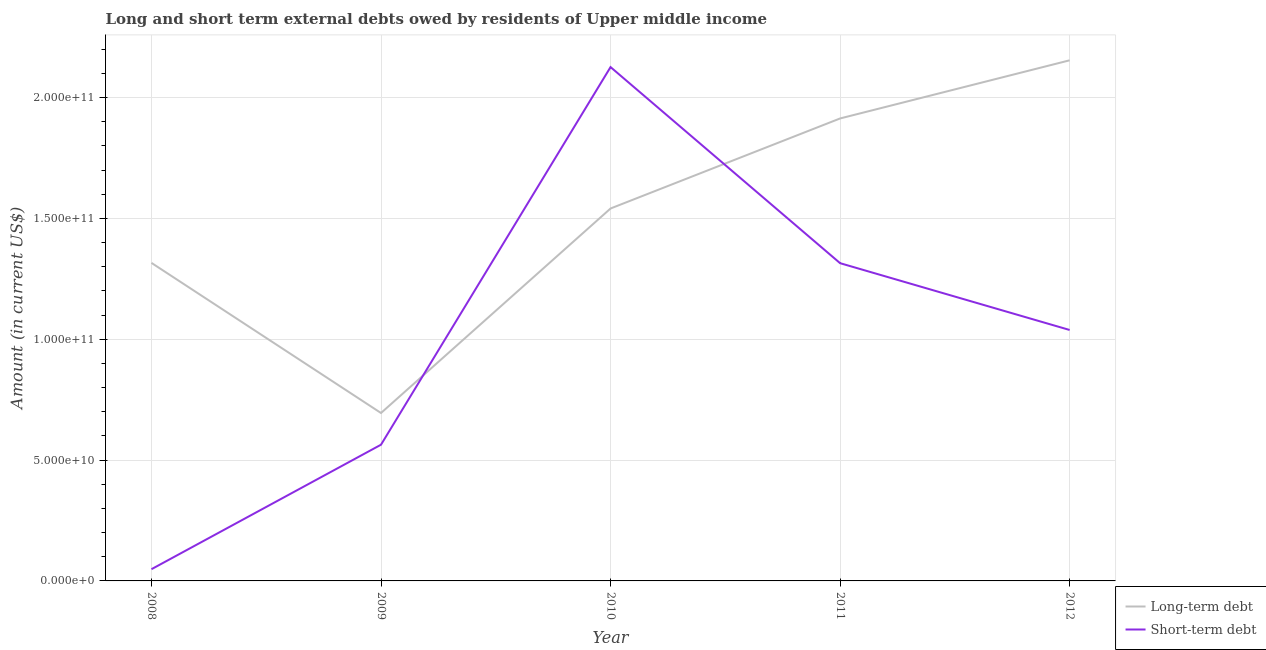Does the line corresponding to long-term debts owed by residents intersect with the line corresponding to short-term debts owed by residents?
Offer a very short reply. Yes. What is the long-term debts owed by residents in 2010?
Provide a short and direct response. 1.54e+11. Across all years, what is the maximum long-term debts owed by residents?
Ensure brevity in your answer.  2.15e+11. Across all years, what is the minimum long-term debts owed by residents?
Your response must be concise. 6.95e+1. What is the total long-term debts owed by residents in the graph?
Your answer should be very brief. 7.62e+11. What is the difference between the short-term debts owed by residents in 2009 and that in 2010?
Your response must be concise. -1.56e+11. What is the difference between the long-term debts owed by residents in 2008 and the short-term debts owed by residents in 2010?
Your response must be concise. -8.10e+1. What is the average long-term debts owed by residents per year?
Keep it short and to the point. 1.52e+11. In the year 2012, what is the difference between the long-term debts owed by residents and short-term debts owed by residents?
Provide a short and direct response. 1.12e+11. What is the ratio of the long-term debts owed by residents in 2009 to that in 2010?
Provide a short and direct response. 0.45. Is the long-term debts owed by residents in 2009 less than that in 2011?
Provide a succinct answer. Yes. Is the difference between the short-term debts owed by residents in 2008 and 2011 greater than the difference between the long-term debts owed by residents in 2008 and 2011?
Your response must be concise. No. What is the difference between the highest and the second highest long-term debts owed by residents?
Provide a short and direct response. 2.41e+1. What is the difference between the highest and the lowest long-term debts owed by residents?
Ensure brevity in your answer.  1.46e+11. In how many years, is the long-term debts owed by residents greater than the average long-term debts owed by residents taken over all years?
Offer a terse response. 3. Is the short-term debts owed by residents strictly greater than the long-term debts owed by residents over the years?
Offer a very short reply. No. What is the difference between two consecutive major ticks on the Y-axis?
Provide a succinct answer. 5.00e+1. Are the values on the major ticks of Y-axis written in scientific E-notation?
Offer a very short reply. Yes. Does the graph contain grids?
Provide a short and direct response. Yes. Where does the legend appear in the graph?
Provide a short and direct response. Bottom right. How are the legend labels stacked?
Ensure brevity in your answer.  Vertical. What is the title of the graph?
Keep it short and to the point. Long and short term external debts owed by residents of Upper middle income. What is the label or title of the X-axis?
Your response must be concise. Year. What is the label or title of the Y-axis?
Offer a very short reply. Amount (in current US$). What is the Amount (in current US$) in Long-term debt in 2008?
Offer a very short reply. 1.32e+11. What is the Amount (in current US$) in Short-term debt in 2008?
Provide a succinct answer. 4.85e+09. What is the Amount (in current US$) of Long-term debt in 2009?
Ensure brevity in your answer.  6.95e+1. What is the Amount (in current US$) in Short-term debt in 2009?
Your answer should be very brief. 5.64e+1. What is the Amount (in current US$) in Long-term debt in 2010?
Keep it short and to the point. 1.54e+11. What is the Amount (in current US$) in Short-term debt in 2010?
Your answer should be compact. 2.13e+11. What is the Amount (in current US$) in Long-term debt in 2011?
Make the answer very short. 1.91e+11. What is the Amount (in current US$) of Short-term debt in 2011?
Make the answer very short. 1.31e+11. What is the Amount (in current US$) in Long-term debt in 2012?
Provide a succinct answer. 2.15e+11. What is the Amount (in current US$) of Short-term debt in 2012?
Make the answer very short. 1.04e+11. Across all years, what is the maximum Amount (in current US$) of Long-term debt?
Ensure brevity in your answer.  2.15e+11. Across all years, what is the maximum Amount (in current US$) of Short-term debt?
Your answer should be very brief. 2.13e+11. Across all years, what is the minimum Amount (in current US$) in Long-term debt?
Give a very brief answer. 6.95e+1. Across all years, what is the minimum Amount (in current US$) of Short-term debt?
Your answer should be very brief. 4.85e+09. What is the total Amount (in current US$) of Long-term debt in the graph?
Give a very brief answer. 7.62e+11. What is the total Amount (in current US$) of Short-term debt in the graph?
Ensure brevity in your answer.  5.09e+11. What is the difference between the Amount (in current US$) in Long-term debt in 2008 and that in 2009?
Give a very brief answer. 6.21e+1. What is the difference between the Amount (in current US$) of Short-term debt in 2008 and that in 2009?
Offer a terse response. -5.15e+1. What is the difference between the Amount (in current US$) of Long-term debt in 2008 and that in 2010?
Your response must be concise. -2.25e+1. What is the difference between the Amount (in current US$) in Short-term debt in 2008 and that in 2010?
Your response must be concise. -2.08e+11. What is the difference between the Amount (in current US$) of Long-term debt in 2008 and that in 2011?
Give a very brief answer. -5.98e+1. What is the difference between the Amount (in current US$) of Short-term debt in 2008 and that in 2011?
Make the answer very short. -1.27e+11. What is the difference between the Amount (in current US$) of Long-term debt in 2008 and that in 2012?
Your response must be concise. -8.38e+1. What is the difference between the Amount (in current US$) in Short-term debt in 2008 and that in 2012?
Make the answer very short. -9.90e+1. What is the difference between the Amount (in current US$) in Long-term debt in 2009 and that in 2010?
Your response must be concise. -8.46e+1. What is the difference between the Amount (in current US$) in Short-term debt in 2009 and that in 2010?
Offer a terse response. -1.56e+11. What is the difference between the Amount (in current US$) of Long-term debt in 2009 and that in 2011?
Offer a terse response. -1.22e+11. What is the difference between the Amount (in current US$) in Short-term debt in 2009 and that in 2011?
Your response must be concise. -7.51e+1. What is the difference between the Amount (in current US$) of Long-term debt in 2009 and that in 2012?
Your answer should be very brief. -1.46e+11. What is the difference between the Amount (in current US$) in Short-term debt in 2009 and that in 2012?
Your response must be concise. -4.75e+1. What is the difference between the Amount (in current US$) in Long-term debt in 2010 and that in 2011?
Ensure brevity in your answer.  -3.73e+1. What is the difference between the Amount (in current US$) of Short-term debt in 2010 and that in 2011?
Offer a very short reply. 8.11e+1. What is the difference between the Amount (in current US$) of Long-term debt in 2010 and that in 2012?
Your answer should be very brief. -6.13e+1. What is the difference between the Amount (in current US$) of Short-term debt in 2010 and that in 2012?
Offer a terse response. 1.09e+11. What is the difference between the Amount (in current US$) of Long-term debt in 2011 and that in 2012?
Offer a terse response. -2.41e+1. What is the difference between the Amount (in current US$) of Short-term debt in 2011 and that in 2012?
Offer a very short reply. 2.76e+1. What is the difference between the Amount (in current US$) of Long-term debt in 2008 and the Amount (in current US$) of Short-term debt in 2009?
Make the answer very short. 7.52e+1. What is the difference between the Amount (in current US$) of Long-term debt in 2008 and the Amount (in current US$) of Short-term debt in 2010?
Your response must be concise. -8.10e+1. What is the difference between the Amount (in current US$) of Long-term debt in 2008 and the Amount (in current US$) of Short-term debt in 2011?
Provide a short and direct response. 1.19e+08. What is the difference between the Amount (in current US$) in Long-term debt in 2008 and the Amount (in current US$) in Short-term debt in 2012?
Make the answer very short. 2.78e+1. What is the difference between the Amount (in current US$) in Long-term debt in 2009 and the Amount (in current US$) in Short-term debt in 2010?
Your answer should be very brief. -1.43e+11. What is the difference between the Amount (in current US$) of Long-term debt in 2009 and the Amount (in current US$) of Short-term debt in 2011?
Offer a terse response. -6.20e+1. What is the difference between the Amount (in current US$) of Long-term debt in 2009 and the Amount (in current US$) of Short-term debt in 2012?
Make the answer very short. -3.44e+1. What is the difference between the Amount (in current US$) in Long-term debt in 2010 and the Amount (in current US$) in Short-term debt in 2011?
Keep it short and to the point. 2.26e+1. What is the difference between the Amount (in current US$) of Long-term debt in 2010 and the Amount (in current US$) of Short-term debt in 2012?
Keep it short and to the point. 5.03e+1. What is the difference between the Amount (in current US$) of Long-term debt in 2011 and the Amount (in current US$) of Short-term debt in 2012?
Offer a terse response. 8.75e+1. What is the average Amount (in current US$) of Long-term debt per year?
Your answer should be compact. 1.52e+11. What is the average Amount (in current US$) of Short-term debt per year?
Provide a succinct answer. 1.02e+11. In the year 2008, what is the difference between the Amount (in current US$) in Long-term debt and Amount (in current US$) in Short-term debt?
Your answer should be compact. 1.27e+11. In the year 2009, what is the difference between the Amount (in current US$) of Long-term debt and Amount (in current US$) of Short-term debt?
Provide a short and direct response. 1.31e+1. In the year 2010, what is the difference between the Amount (in current US$) of Long-term debt and Amount (in current US$) of Short-term debt?
Your answer should be very brief. -5.85e+1. In the year 2011, what is the difference between the Amount (in current US$) of Long-term debt and Amount (in current US$) of Short-term debt?
Ensure brevity in your answer.  5.99e+1. In the year 2012, what is the difference between the Amount (in current US$) of Long-term debt and Amount (in current US$) of Short-term debt?
Ensure brevity in your answer.  1.12e+11. What is the ratio of the Amount (in current US$) of Long-term debt in 2008 to that in 2009?
Provide a succinct answer. 1.89. What is the ratio of the Amount (in current US$) in Short-term debt in 2008 to that in 2009?
Offer a very short reply. 0.09. What is the ratio of the Amount (in current US$) of Long-term debt in 2008 to that in 2010?
Provide a short and direct response. 0.85. What is the ratio of the Amount (in current US$) in Short-term debt in 2008 to that in 2010?
Ensure brevity in your answer.  0.02. What is the ratio of the Amount (in current US$) of Long-term debt in 2008 to that in 2011?
Your answer should be very brief. 0.69. What is the ratio of the Amount (in current US$) of Short-term debt in 2008 to that in 2011?
Offer a terse response. 0.04. What is the ratio of the Amount (in current US$) in Long-term debt in 2008 to that in 2012?
Provide a short and direct response. 0.61. What is the ratio of the Amount (in current US$) of Short-term debt in 2008 to that in 2012?
Offer a very short reply. 0.05. What is the ratio of the Amount (in current US$) in Long-term debt in 2009 to that in 2010?
Provide a short and direct response. 0.45. What is the ratio of the Amount (in current US$) in Short-term debt in 2009 to that in 2010?
Give a very brief answer. 0.27. What is the ratio of the Amount (in current US$) of Long-term debt in 2009 to that in 2011?
Keep it short and to the point. 0.36. What is the ratio of the Amount (in current US$) of Short-term debt in 2009 to that in 2011?
Ensure brevity in your answer.  0.43. What is the ratio of the Amount (in current US$) of Long-term debt in 2009 to that in 2012?
Your answer should be very brief. 0.32. What is the ratio of the Amount (in current US$) of Short-term debt in 2009 to that in 2012?
Provide a short and direct response. 0.54. What is the ratio of the Amount (in current US$) in Long-term debt in 2010 to that in 2011?
Provide a short and direct response. 0.81. What is the ratio of the Amount (in current US$) in Short-term debt in 2010 to that in 2011?
Ensure brevity in your answer.  1.62. What is the ratio of the Amount (in current US$) in Long-term debt in 2010 to that in 2012?
Ensure brevity in your answer.  0.72. What is the ratio of the Amount (in current US$) in Short-term debt in 2010 to that in 2012?
Your answer should be compact. 2.05. What is the ratio of the Amount (in current US$) in Long-term debt in 2011 to that in 2012?
Your answer should be very brief. 0.89. What is the ratio of the Amount (in current US$) of Short-term debt in 2011 to that in 2012?
Provide a succinct answer. 1.27. What is the difference between the highest and the second highest Amount (in current US$) in Long-term debt?
Ensure brevity in your answer.  2.41e+1. What is the difference between the highest and the second highest Amount (in current US$) in Short-term debt?
Your answer should be compact. 8.11e+1. What is the difference between the highest and the lowest Amount (in current US$) of Long-term debt?
Offer a terse response. 1.46e+11. What is the difference between the highest and the lowest Amount (in current US$) in Short-term debt?
Your answer should be very brief. 2.08e+11. 